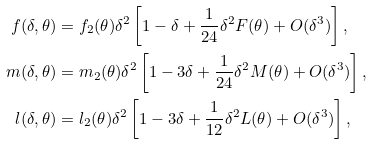<formula> <loc_0><loc_0><loc_500><loc_500>f ( \delta , \theta ) & = f _ { 2 } ( \theta ) \delta ^ { 2 } \left [ 1 - \delta + \frac { 1 } { 2 4 } \delta ^ { 2 } F ( \theta ) + O ( \delta ^ { 3 } ) \right ] , \\ m ( \delta , \theta ) & = m _ { 2 } ( \theta ) \delta ^ { 2 } \left [ 1 - 3 \delta + \frac { 1 } { 2 4 } \delta ^ { 2 } M ( \theta ) + O ( \delta ^ { 3 } ) \right ] , \\ l ( \delta , \theta ) & = l _ { 2 } ( \theta ) \delta ^ { 2 } \left [ 1 - 3 \delta + \frac { 1 } { 1 2 } \delta ^ { 2 } L ( \theta ) + O ( \delta ^ { 3 } ) \right ] ,</formula> 